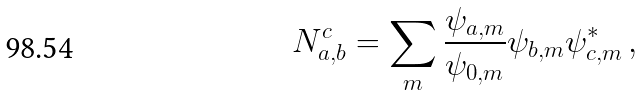<formula> <loc_0><loc_0><loc_500><loc_500>N _ { a , b } ^ { c } = \sum _ { m } \frac { \psi _ { a , m } } { \psi _ { 0 , m } } \psi _ { b , m } \psi _ { c , m } ^ { * } \, ,</formula> 